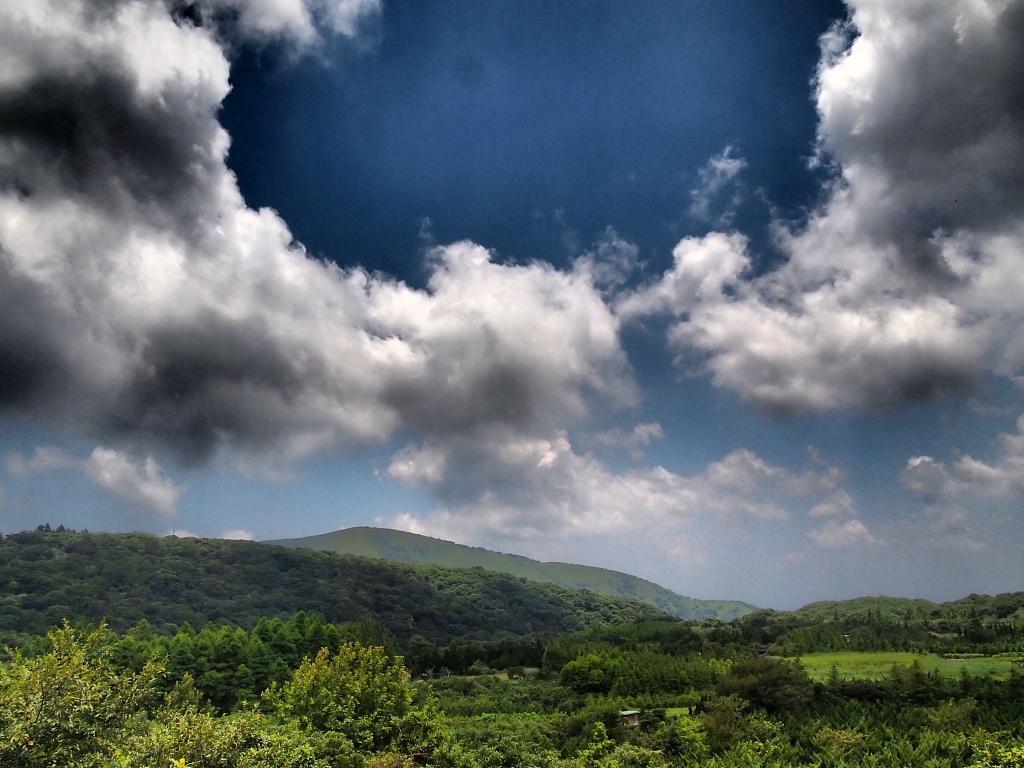Describe this image in one or two sentences. In this image there are plants, trees, hills and in the background there is sky. 